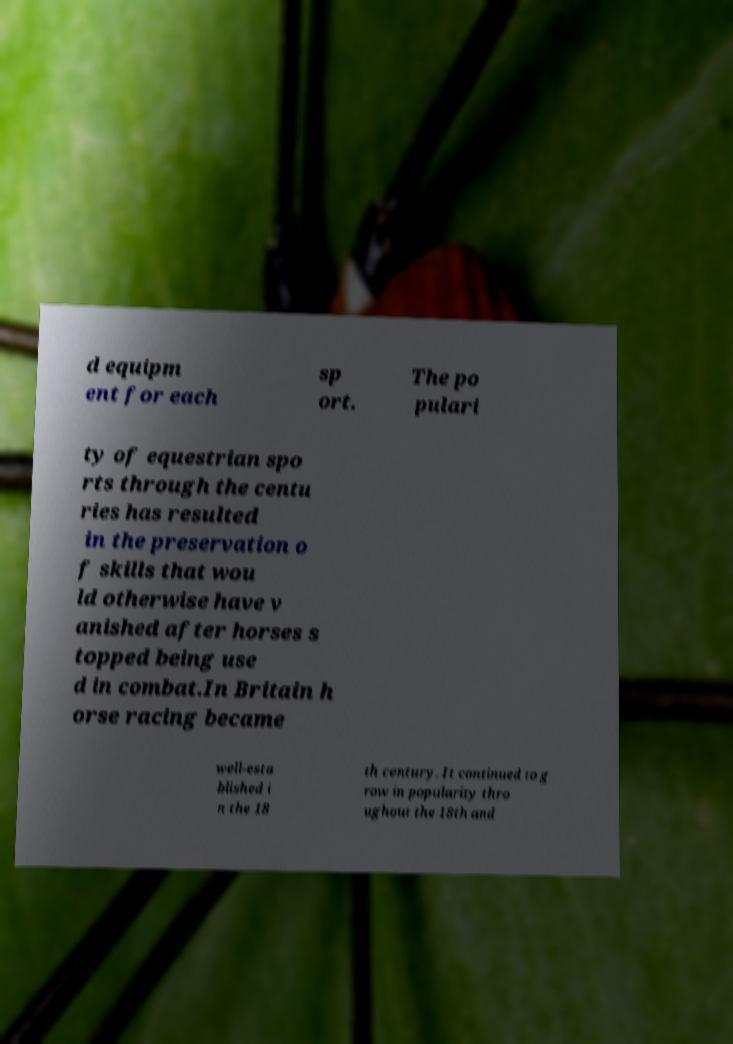I need the written content from this picture converted into text. Can you do that? d equipm ent for each sp ort. The po pulari ty of equestrian spo rts through the centu ries has resulted in the preservation o f skills that wou ld otherwise have v anished after horses s topped being use d in combat.In Britain h orse racing became well-esta blished i n the 18 th century. It continued to g row in popularity thro ughout the 18th and 